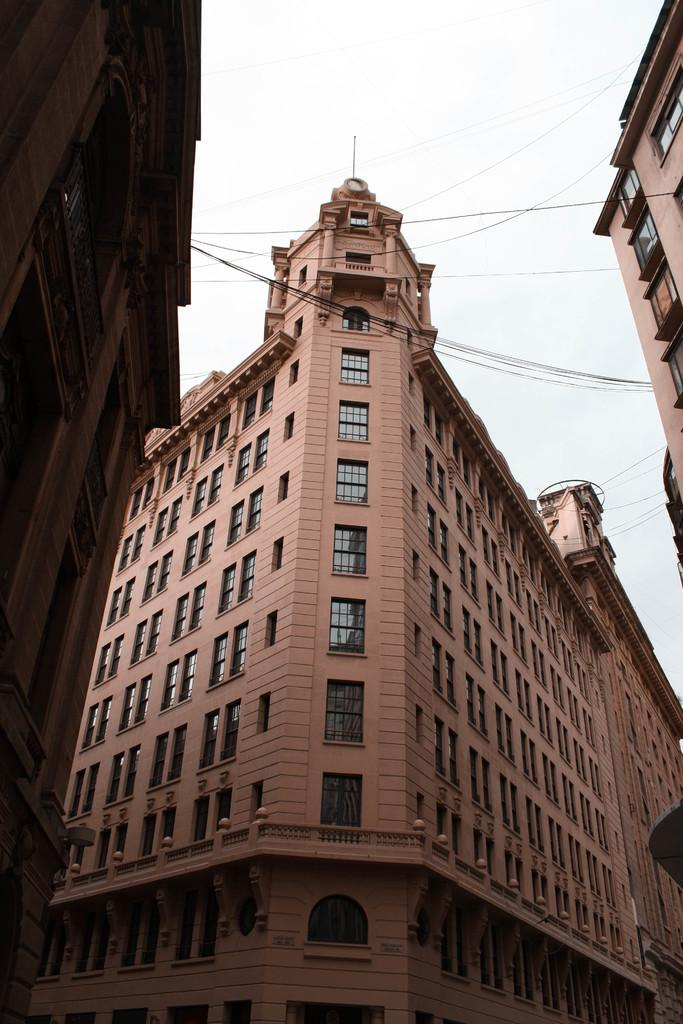What type of structures can be seen in the image? There are buildings in the image. What else is present in the image besides the buildings? There are wires in the image. What can be seen in the background of the image? The sky is visible in the background of the image. Can you tell me how many chickens are in the room in the image? There is no room or chicken present in the image. What type of burst can be seen in the image? There is no burst present in the image. 